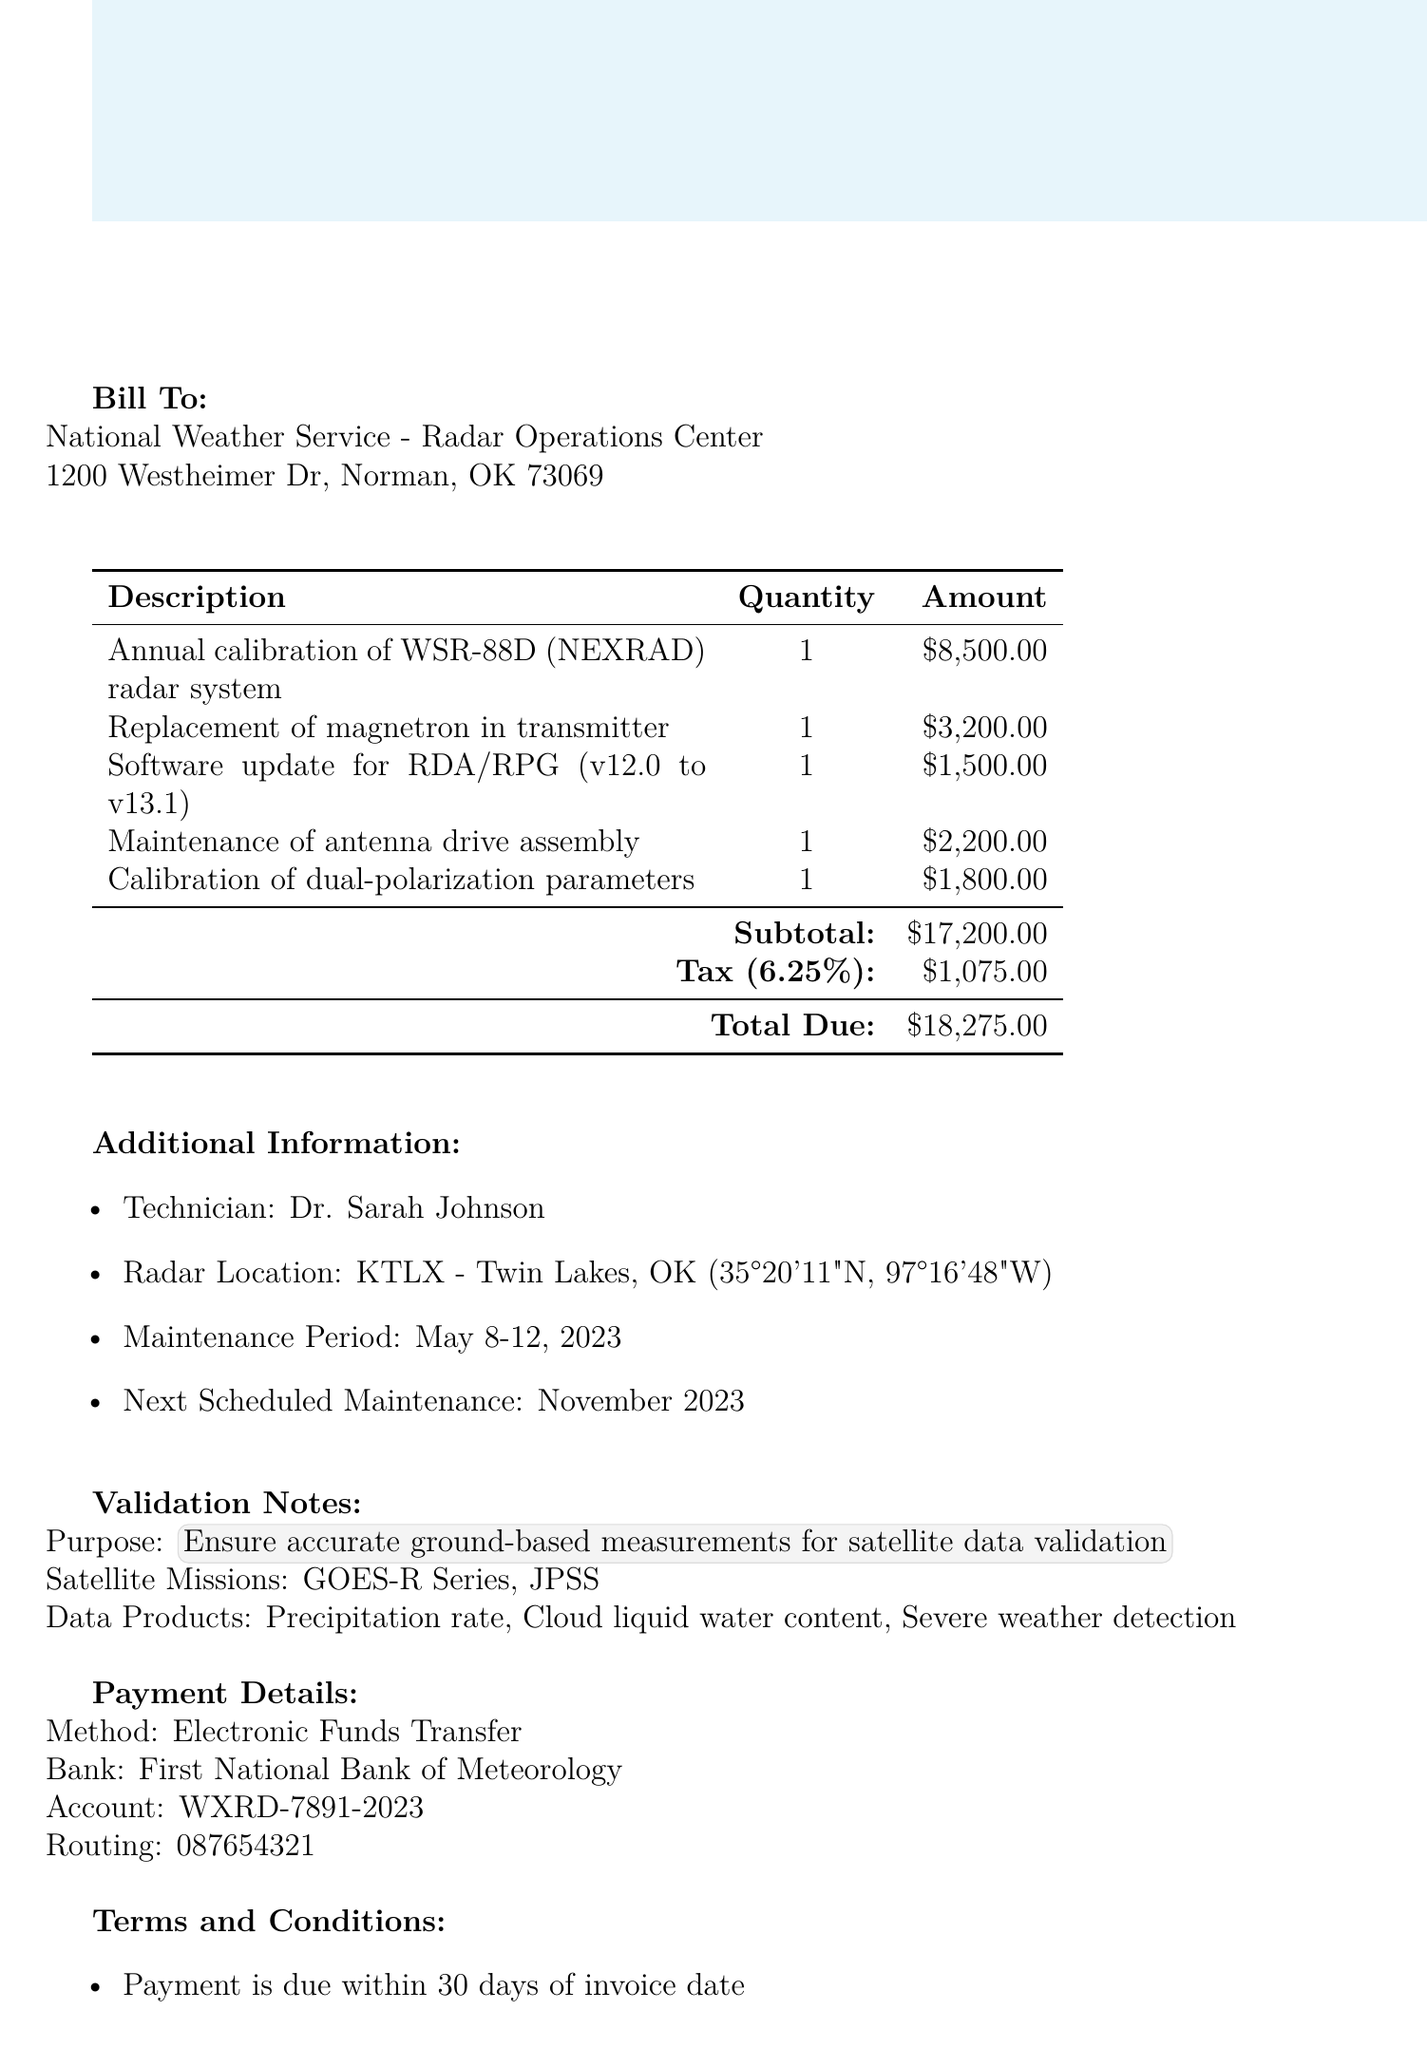What is the invoice number? The invoice number is specifically noted in the document under invoice details.
Answer: WR-2023-0542 What is the total due amount? The total due is calculated by adding the subtotal and tax amount in the payment details section.
Answer: $18275.00 Who is the service provider? The service provider's information is provided in the invoice details.
Answer: Advanced Radar Technologies, Inc What is the maintenance period? The maintenance period is specified in the additional information section of the document.
Answer: May 8-12, 2023 What is the tax rate applied? The tax rate is mentioned in the payment details section.
Answer: 6.25% What services were rendered in this invoice? This involves summarizing multiple entries under the services section; the entries represent distinct services provided.
Answer: Annual calibration, Replacement of magnetron, Software update, Maintenance of antenna drive, Calibration of parameters What is the name of the technician? The name of the technician is mentioned in the additional information section.
Answer: Dr. Sarah Johnson When is the next scheduled maintenance? The next scheduled maintenance date is specified in the additional information section.
Answer: November 2023 What type of payment method is accepted? The payment method is stated clearly in the payment details section.
Answer: Electronic Funds Transfer What is the warranty period for parts and labor? The warranty period is described in the terms and conditions section of the document.
Answer: 90 days 